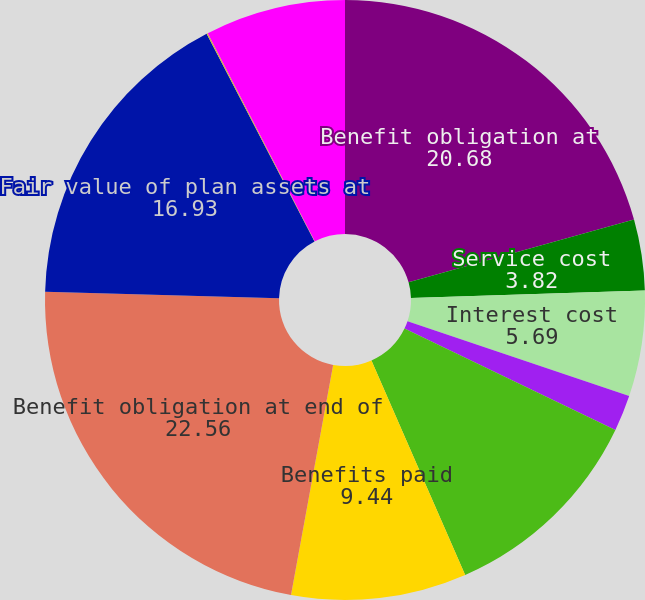Convert chart to OTSL. <chart><loc_0><loc_0><loc_500><loc_500><pie_chart><fcel>Benefit obligation at<fcel>Service cost<fcel>Interest cost<fcel>Plan participants'<fcel>Actuarial (gain) loss<fcel>Benefits paid<fcel>Benefit obligation at end of<fcel>Fair value of plan assets at<fcel>Actual return on plan assets<fcel>Employer contributions<nl><fcel>20.68%<fcel>3.82%<fcel>5.69%<fcel>1.94%<fcel>11.31%<fcel>9.44%<fcel>22.56%<fcel>16.93%<fcel>0.07%<fcel>7.56%<nl></chart> 